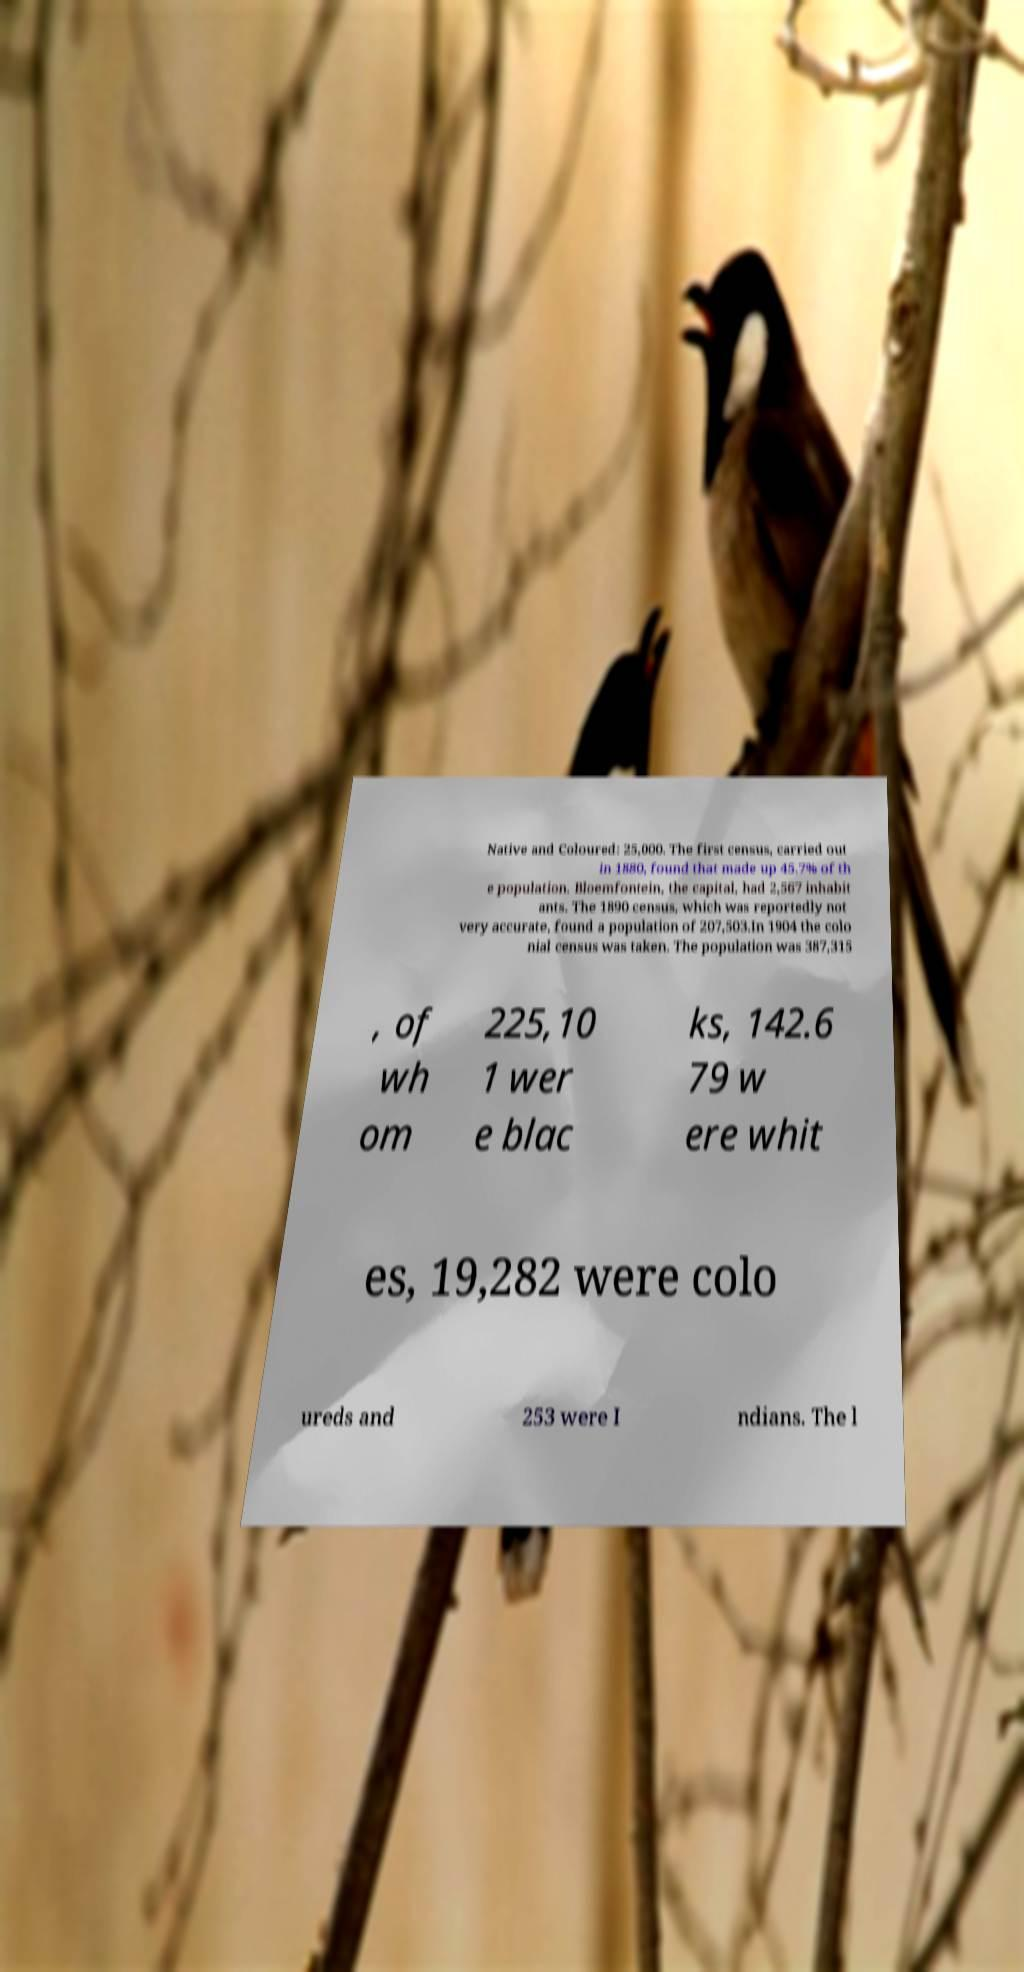Please identify and transcribe the text found in this image. Native and Coloured: 25,000. The first census, carried out in 1880, found that made up 45.7% of th e population. Bloemfontein, the capital, had 2,567 inhabit ants. The 1890 census, which was reportedly not very accurate, found a population of 207,503.In 1904 the colo nial census was taken. The population was 387,315 , of wh om 225,10 1 wer e blac ks, 142.6 79 w ere whit es, 19,282 were colo ureds and 253 were I ndians. The l 